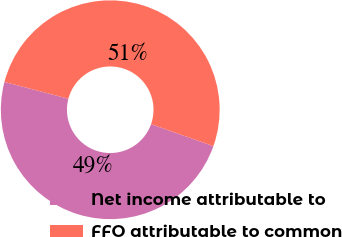Convert chart. <chart><loc_0><loc_0><loc_500><loc_500><pie_chart><fcel>Net income attributable to<fcel>FFO attributable to common<nl><fcel>48.7%<fcel>51.3%<nl></chart> 